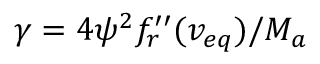Convert formula to latex. <formula><loc_0><loc_0><loc_500><loc_500>\gamma = 4 { \psi } ^ { 2 } f _ { r } ^ { \prime \prime } ( v _ { e q } ) / M _ { a }</formula> 